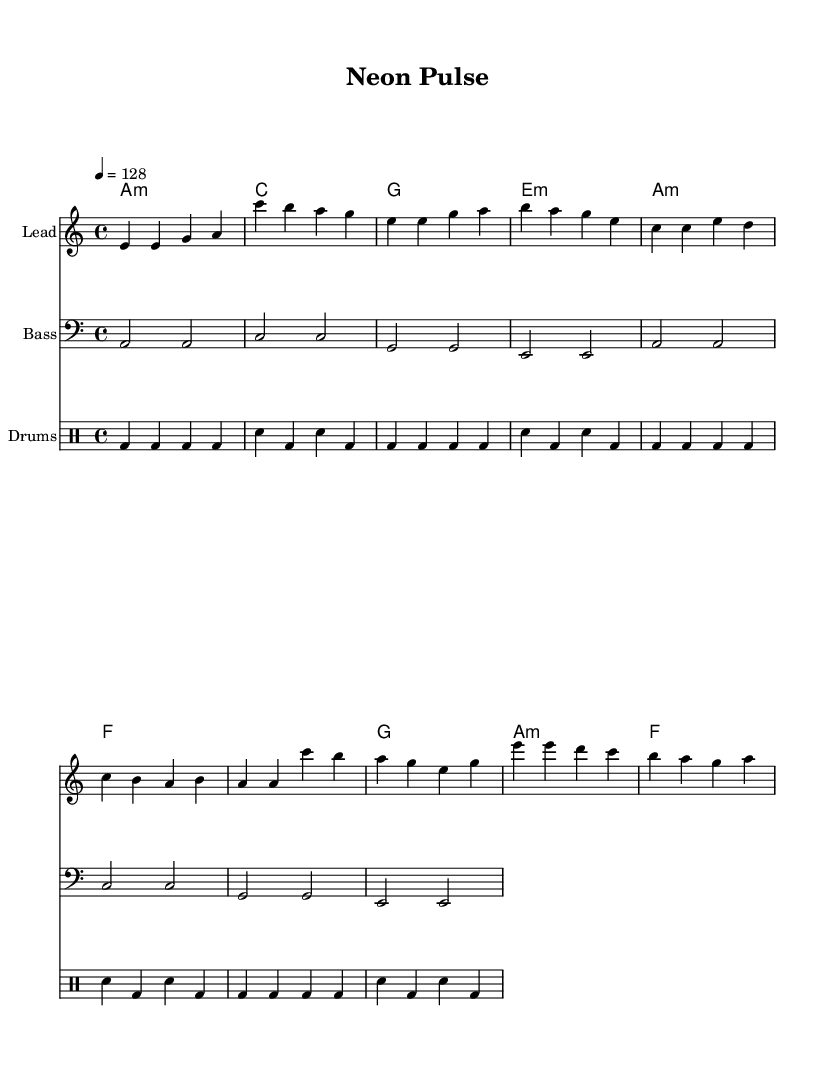What is the key signature of this music? The key signature is A minor, indicated by the lack of sharps or flats.
Answer: A minor What is the time signature of this music? The time signature is 4/4, which is indicated at the beginning of the music.
Answer: 4/4 What is the tempo of the piece? The tempo marking indicates a speed of 128 beats per minute, noted by the tempo text.
Answer: 128 How many measures are in the melodic section provided? The melody section consists of a total of 8 measures, with each group separated by bar lines.
Answer: 8 measures What type of rhythmic pattern is primarily used in the drum part? The drum part primarily uses a bass drum and snare pattern, alternating every two beats consistently.
Answer: Alternating bass and snare In the chorus section, which note appears most frequently? The note 'a' appears most frequently in the chorus section, as it is repeated in measures.
Answer: a What chord is played in the introduction? The introduction features an A minor chord, indicated by the chord symbols above the staff.
Answer: A minor 